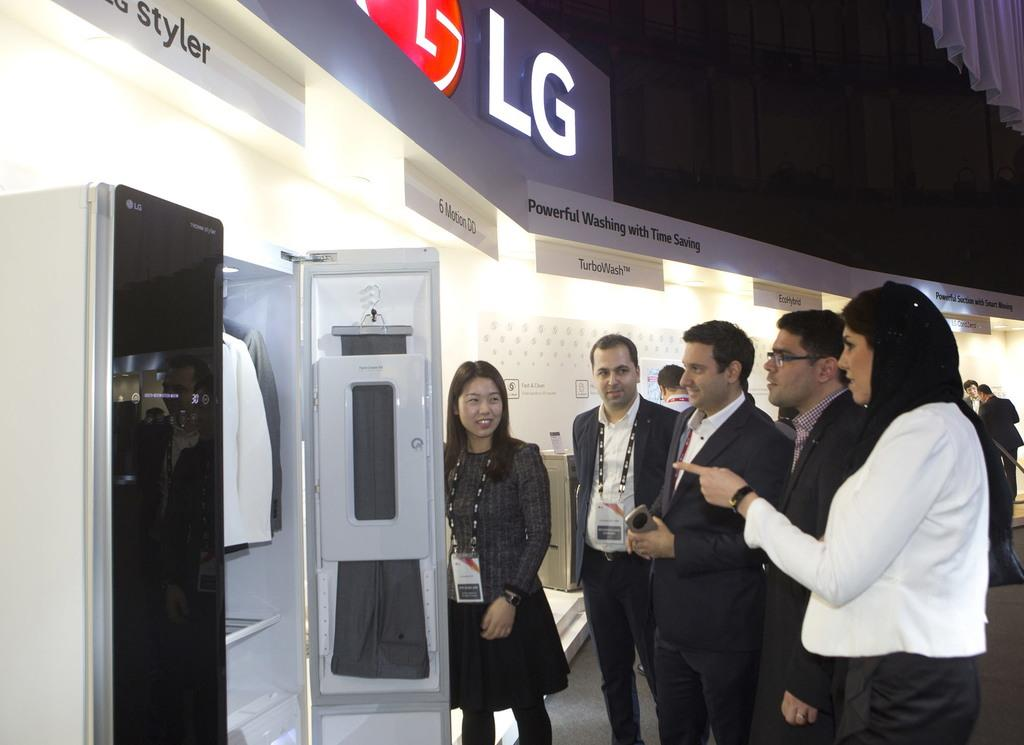<image>
Create a compact narrative representing the image presented. People in business clothes stand around an LG refrigerator. 